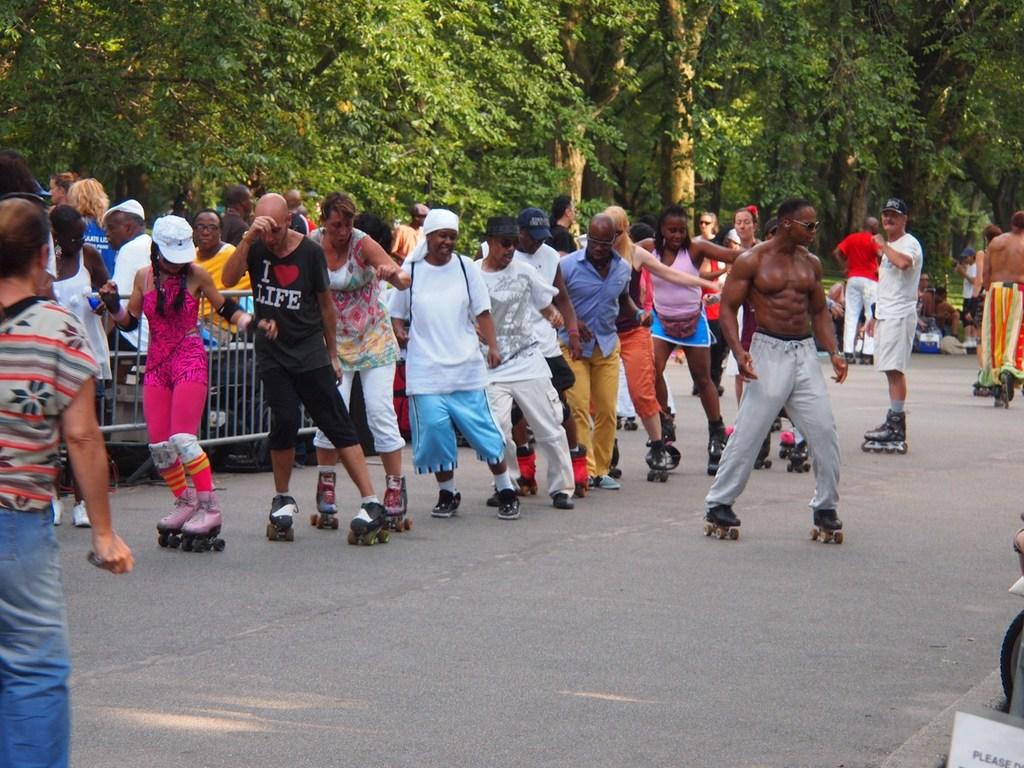What activity are the people in the center of the picture engaged in? The people in the center of the picture are skating. On what surface are they skating? They are skating on a road. What can be seen in the background of the image? There are trees, people sitting on benches, and a footpath in the background. What type of finger can be seen holding a piece of trade cloth in the image? There is no finger or trade cloth present in the image. 